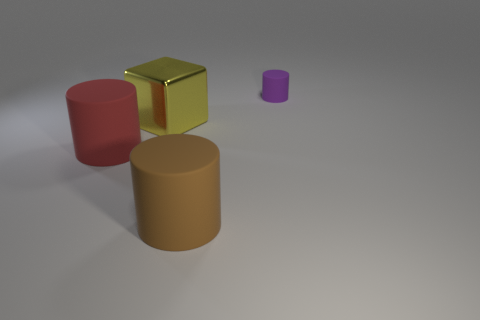Add 4 small gray balls. How many objects exist? 8 Subtract all big matte cylinders. How many cylinders are left? 1 Subtract all brown cylinders. How many cylinders are left? 2 Subtract 0 brown balls. How many objects are left? 4 Subtract all cylinders. How many objects are left? 1 Subtract 2 cylinders. How many cylinders are left? 1 Subtract all brown cubes. Subtract all yellow cylinders. How many cubes are left? 1 Subtract all purple balls. How many green cylinders are left? 0 Subtract all purple matte cubes. Subtract all purple cylinders. How many objects are left? 3 Add 3 big rubber things. How many big rubber things are left? 5 